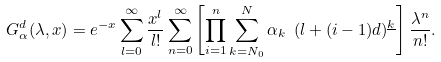Convert formula to latex. <formula><loc_0><loc_0><loc_500><loc_500>G _ { \alpha } ^ { d } ( \lambda , x ) = e ^ { - x } \sum _ { l = 0 } ^ { \infty } \frac { x ^ { l } } { l ! } \sum _ { n = 0 } ^ { \infty } \left [ \prod _ { i = 1 } ^ { n } \sum _ { k = N _ { 0 } } ^ { N } \alpha _ { k } \ ( l + ( i - 1 ) d ) ^ { \underline { k } } \right ] \frac { \lambda ^ { n } } { n ! } .</formula> 